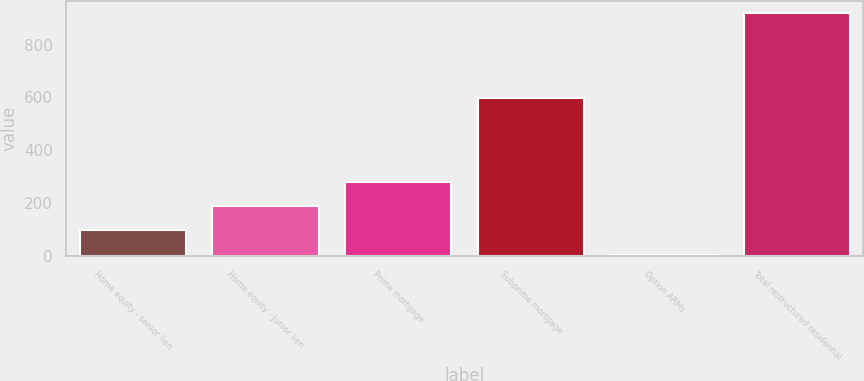Convert chart. <chart><loc_0><loc_0><loc_500><loc_500><bar_chart><fcel>Home equity - senior lien<fcel>Home equity - junior lien<fcel>Prime mortgage<fcel>Subprime mortgage<fcel>Option ARMs<fcel>Total restructured residential<nl><fcel>97.4<fcel>188.8<fcel>280.2<fcel>598<fcel>6<fcel>920<nl></chart> 